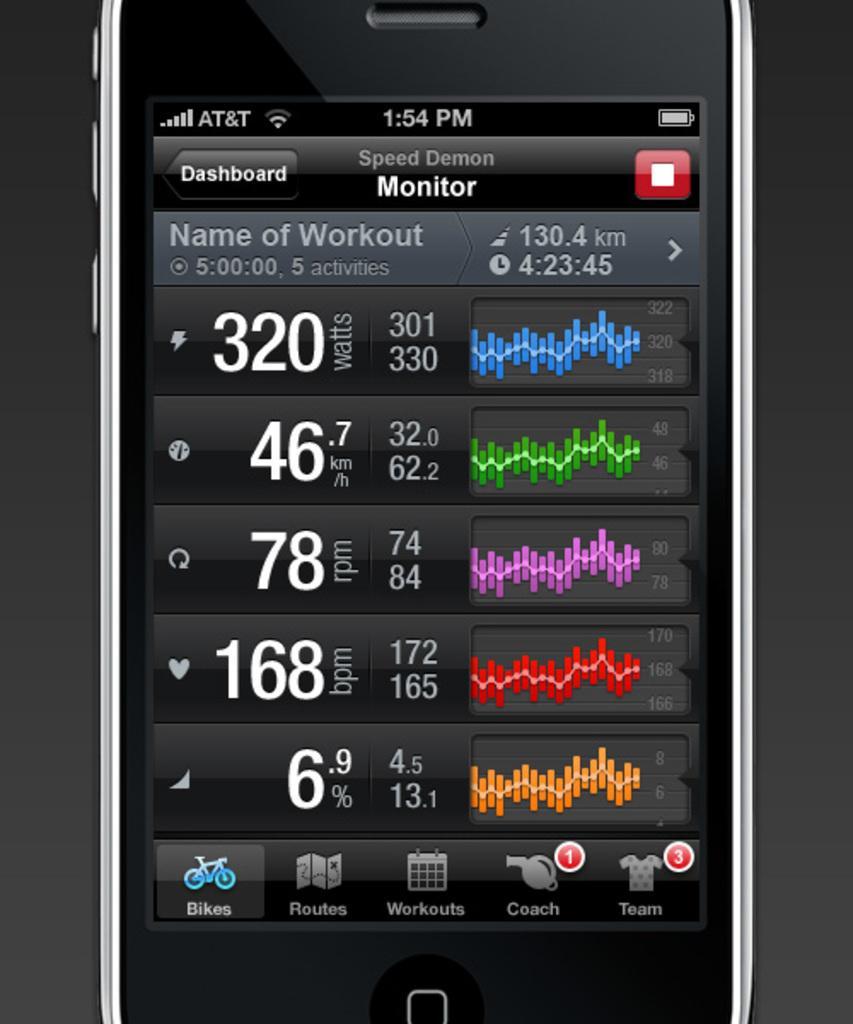Please provide a concise description of this image. In the image there is a mobile phone and on the mobile phone screen there is a dashboard. 